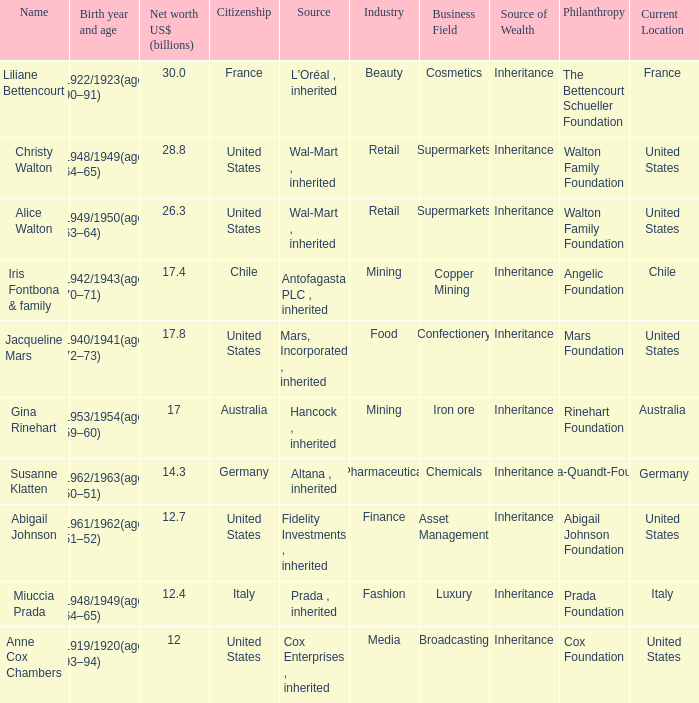What's the source of wealth of the person worth $17 billion? Hancock , inherited. 